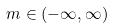Convert formula to latex. <formula><loc_0><loc_0><loc_500><loc_500>m \in ( - \infty , \infty )</formula> 